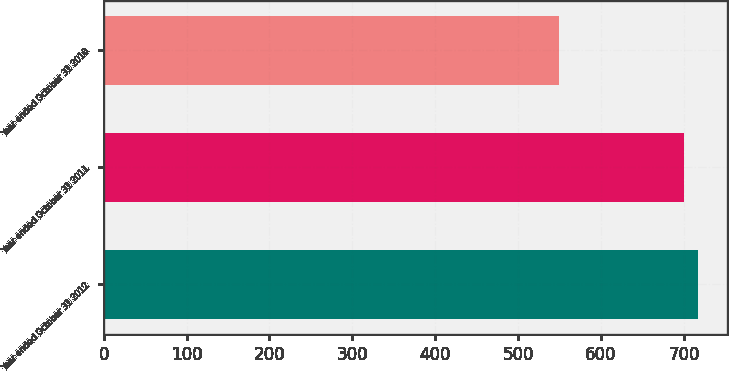Convert chart to OTSL. <chart><loc_0><loc_0><loc_500><loc_500><bar_chart><fcel>Year ended October 31 2012<fcel>Year ended October 31 2011<fcel>Year ended October 31 2010<nl><fcel>716.7<fcel>700<fcel>549<nl></chart> 